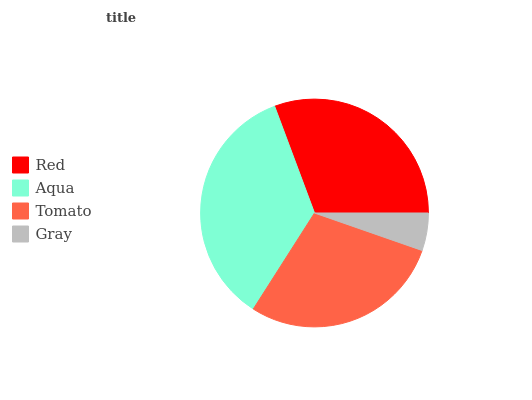Is Gray the minimum?
Answer yes or no. Yes. Is Aqua the maximum?
Answer yes or no. Yes. Is Tomato the minimum?
Answer yes or no. No. Is Tomato the maximum?
Answer yes or no. No. Is Aqua greater than Tomato?
Answer yes or no. Yes. Is Tomato less than Aqua?
Answer yes or no. Yes. Is Tomato greater than Aqua?
Answer yes or no. No. Is Aqua less than Tomato?
Answer yes or no. No. Is Red the high median?
Answer yes or no. Yes. Is Tomato the low median?
Answer yes or no. Yes. Is Gray the high median?
Answer yes or no. No. Is Red the low median?
Answer yes or no. No. 